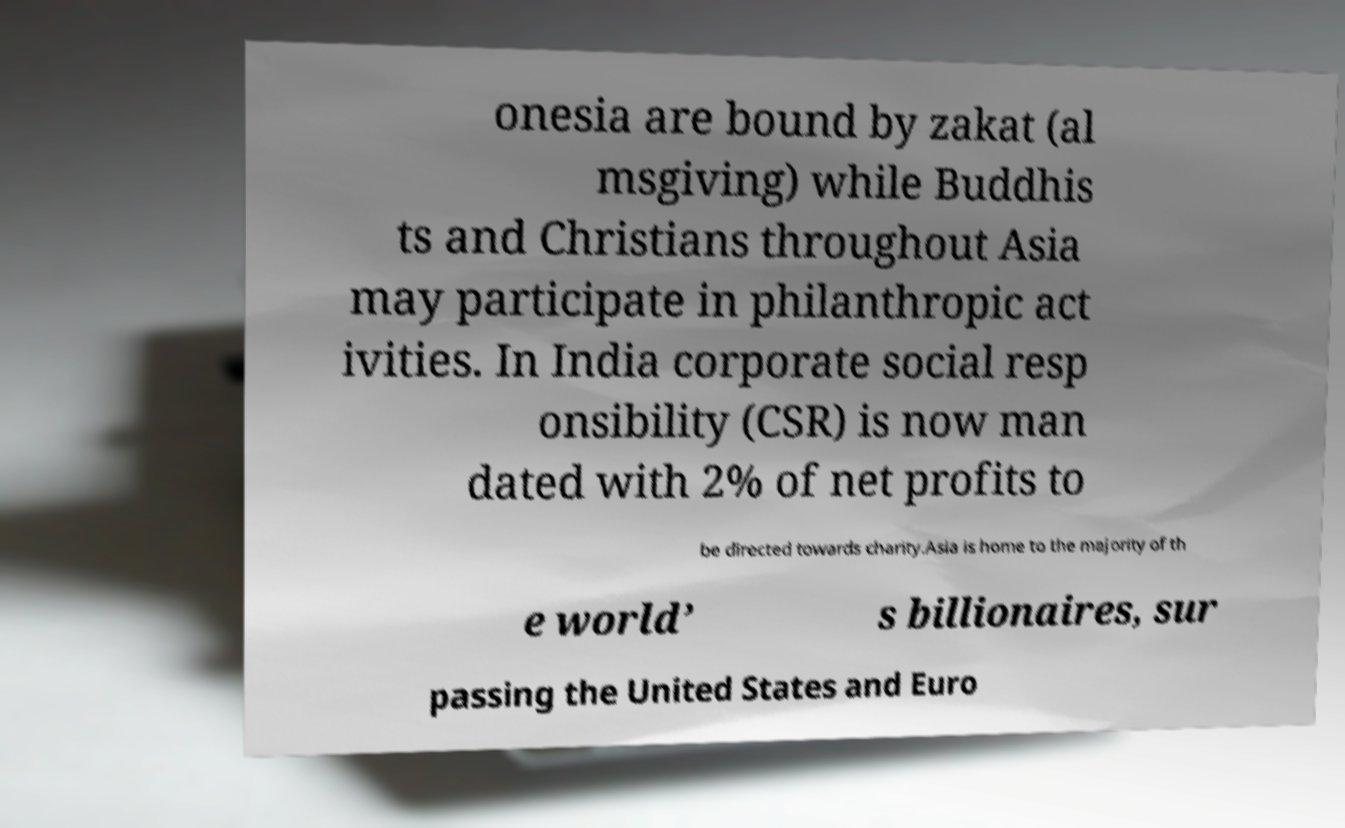Could you assist in decoding the text presented in this image and type it out clearly? onesia are bound by zakat (al msgiving) while Buddhis ts and Christians throughout Asia may participate in philanthropic act ivities. In India corporate social resp onsibility (CSR) is now man dated with 2% of net profits to be directed towards charity.Asia is home to the majority of th e world’ s billionaires, sur passing the United States and Euro 